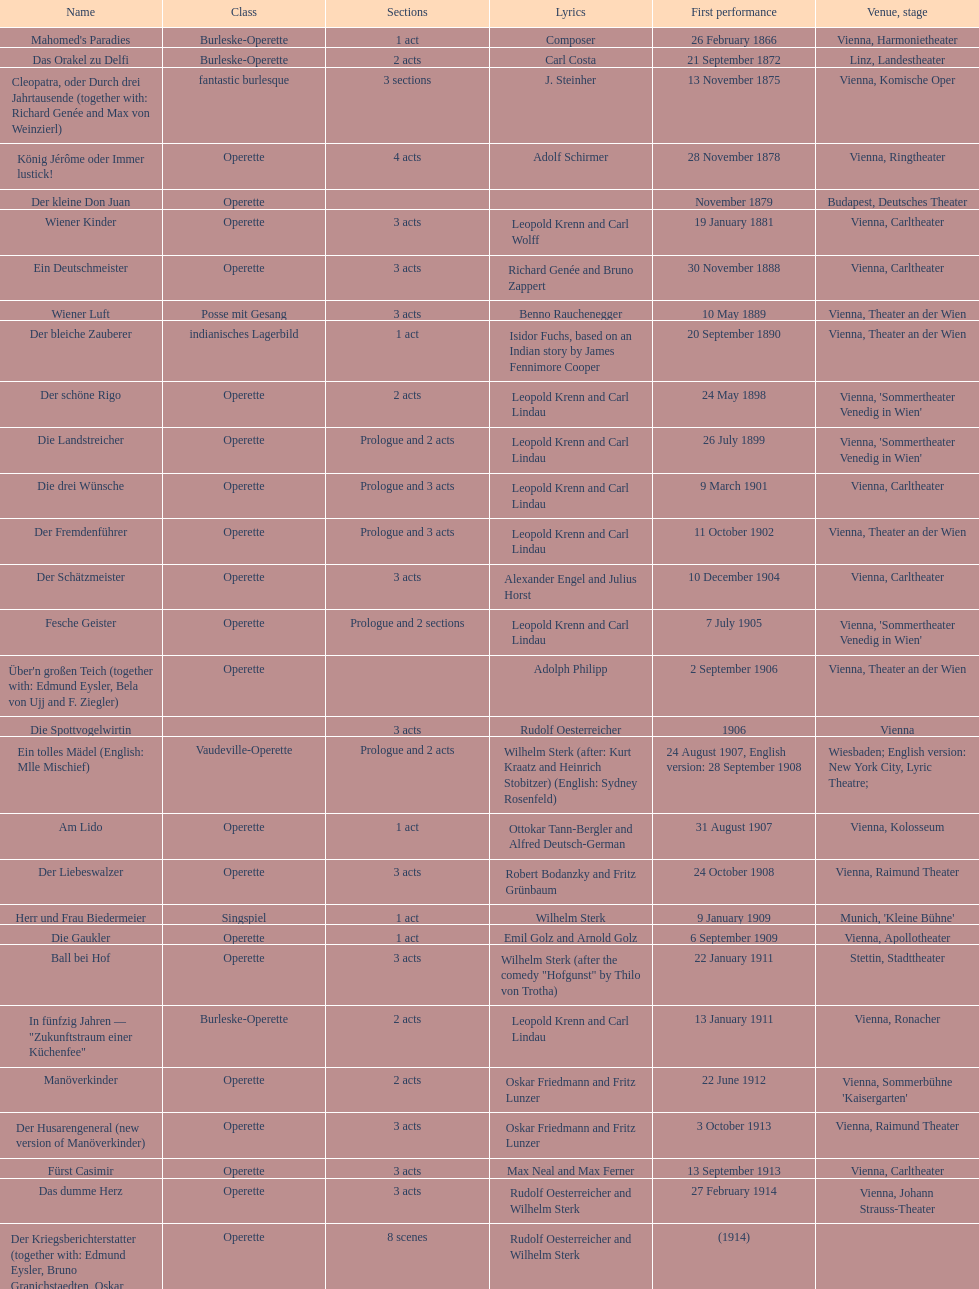Write the full table. {'header': ['Name', 'Class', 'Sections', 'Lyrics', 'First performance', 'Venue, stage'], 'rows': [["Mahomed's Paradies", 'Burleske-Operette', '1 act', 'Composer', '26 February 1866', 'Vienna, Harmonietheater'], ['Das Orakel zu Delfi', 'Burleske-Operette', '2 acts', 'Carl Costa', '21 September 1872', 'Linz, Landestheater'], ['Cleopatra, oder Durch drei Jahrtausende (together with: Richard Genée and Max von Weinzierl)', 'fantastic burlesque', '3 sections', 'J. Steinher', '13 November 1875', 'Vienna, Komische Oper'], ['König Jérôme oder Immer lustick!', 'Operette', '4 acts', 'Adolf Schirmer', '28 November 1878', 'Vienna, Ringtheater'], ['Der kleine Don Juan', 'Operette', '', '', 'November 1879', 'Budapest, Deutsches Theater'], ['Wiener Kinder', 'Operette', '3 acts', 'Leopold Krenn and Carl Wolff', '19 January 1881', 'Vienna, Carltheater'], ['Ein Deutschmeister', 'Operette', '3 acts', 'Richard Genée and Bruno Zappert', '30 November 1888', 'Vienna, Carltheater'], ['Wiener Luft', 'Posse mit Gesang', '3 acts', 'Benno Rauchenegger', '10 May 1889', 'Vienna, Theater an der Wien'], ['Der bleiche Zauberer', 'indianisches Lagerbild', '1 act', 'Isidor Fuchs, based on an Indian story by James Fennimore Cooper', '20 September 1890', 'Vienna, Theater an der Wien'], ['Der schöne Rigo', 'Operette', '2 acts', 'Leopold Krenn and Carl Lindau', '24 May 1898', "Vienna, 'Sommertheater Venedig in Wien'"], ['Die Landstreicher', 'Operette', 'Prologue and 2 acts', 'Leopold Krenn and Carl Lindau', '26 July 1899', "Vienna, 'Sommertheater Venedig in Wien'"], ['Die drei Wünsche', 'Operette', 'Prologue and 3 acts', 'Leopold Krenn and Carl Lindau', '9 March 1901', 'Vienna, Carltheater'], ['Der Fremdenführer', 'Operette', 'Prologue and 3 acts', 'Leopold Krenn and Carl Lindau', '11 October 1902', 'Vienna, Theater an der Wien'], ['Der Schätzmeister', 'Operette', '3 acts', 'Alexander Engel and Julius Horst', '10 December 1904', 'Vienna, Carltheater'], ['Fesche Geister', 'Operette', 'Prologue and 2 sections', 'Leopold Krenn and Carl Lindau', '7 July 1905', "Vienna, 'Sommertheater Venedig in Wien'"], ["Über'n großen Teich (together with: Edmund Eysler, Bela von Ujj and F. Ziegler)", 'Operette', '', 'Adolph Philipp', '2 September 1906', 'Vienna, Theater an der Wien'], ['Die Spottvogelwirtin', '', '3 acts', 'Rudolf Oesterreicher', '1906', 'Vienna'], ['Ein tolles Mädel (English: Mlle Mischief)', 'Vaudeville-Operette', 'Prologue and 2 acts', 'Wilhelm Sterk (after: Kurt Kraatz and Heinrich Stobitzer) (English: Sydney Rosenfeld)', '24 August 1907, English version: 28 September 1908', 'Wiesbaden; English version: New York City, Lyric Theatre;'], ['Am Lido', 'Operette', '1 act', 'Ottokar Tann-Bergler and Alfred Deutsch-German', '31 August 1907', 'Vienna, Kolosseum'], ['Der Liebeswalzer', 'Operette', '3 acts', 'Robert Bodanzky and Fritz Grünbaum', '24 October 1908', 'Vienna, Raimund Theater'], ['Herr und Frau Biedermeier', 'Singspiel', '1 act', 'Wilhelm Sterk', '9 January 1909', "Munich, 'Kleine Bühne'"], ['Die Gaukler', 'Operette', '1 act', 'Emil Golz and Arnold Golz', '6 September 1909', 'Vienna, Apollotheater'], ['Ball bei Hof', 'Operette', '3 acts', 'Wilhelm Sterk (after the comedy "Hofgunst" by Thilo von Trotha)', '22 January 1911', 'Stettin, Stadttheater'], ['In fünfzig Jahren — "Zukunftstraum einer Küchenfee"', 'Burleske-Operette', '2 acts', 'Leopold Krenn and Carl Lindau', '13 January 1911', 'Vienna, Ronacher'], ['Manöverkinder', 'Operette', '2 acts', 'Oskar Friedmann and Fritz Lunzer', '22 June 1912', "Vienna, Sommerbühne 'Kaisergarten'"], ['Der Husarengeneral (new version of Manöverkinder)', 'Operette', '3 acts', 'Oskar Friedmann and Fritz Lunzer', '3 October 1913', 'Vienna, Raimund Theater'], ['Fürst Casimir', 'Operette', '3 acts', 'Max Neal and Max Ferner', '13 September 1913', 'Vienna, Carltheater'], ['Das dumme Herz', 'Operette', '3 acts', 'Rudolf Oesterreicher and Wilhelm Sterk', '27 February 1914', 'Vienna, Johann Strauss-Theater'], ['Der Kriegsberichterstatter (together with: Edmund Eysler, Bruno Granichstaedten, Oskar Nedbal, Charles Weinberger)', 'Operette', '8 scenes', 'Rudolf Oesterreicher and Wilhelm Sterk', '(1914)', ''], ['Im siebenten Himmel', 'Operette', '3 acts', 'Max Neal and Max Ferner', '26 February 1916', 'Munich, Theater am Gärtnerplatz'], ['Deutschmeisterkapelle', 'Operette', '', 'Hubert Marischka and Rudolf Oesterreicher', '30 May 1958', 'Vienna, Raimund Theater'], ['Die verliebte Eskadron', 'Operette', '3 acts', 'Wilhelm Sterk (after B. Buchbinder)', '11 July 1930', 'Vienna, Johann-Strauß-Theater']]} Which genre is featured the most in this chart? Operette. 